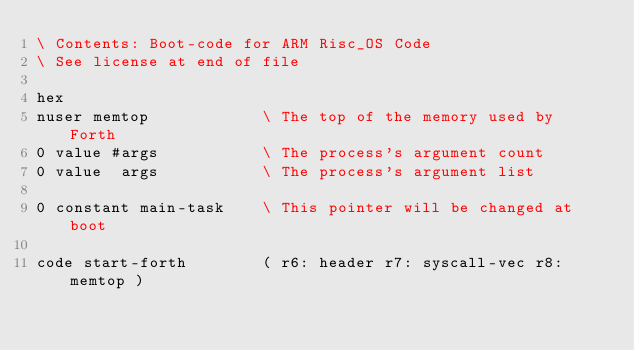<code> <loc_0><loc_0><loc_500><loc_500><_Forth_>\ Contents: Boot-code for ARM Risc_OS Code
\ See license at end of file

hex
nuser memtop            \ The top of the memory used by Forth
0 value #args           \ The process's argument count
0 value  args           \ The process's argument list

0 constant main-task    \ This pointer will be changed at boot

code start-forth        ( r6: header r7: syscall-vec r8: memtop )</code> 